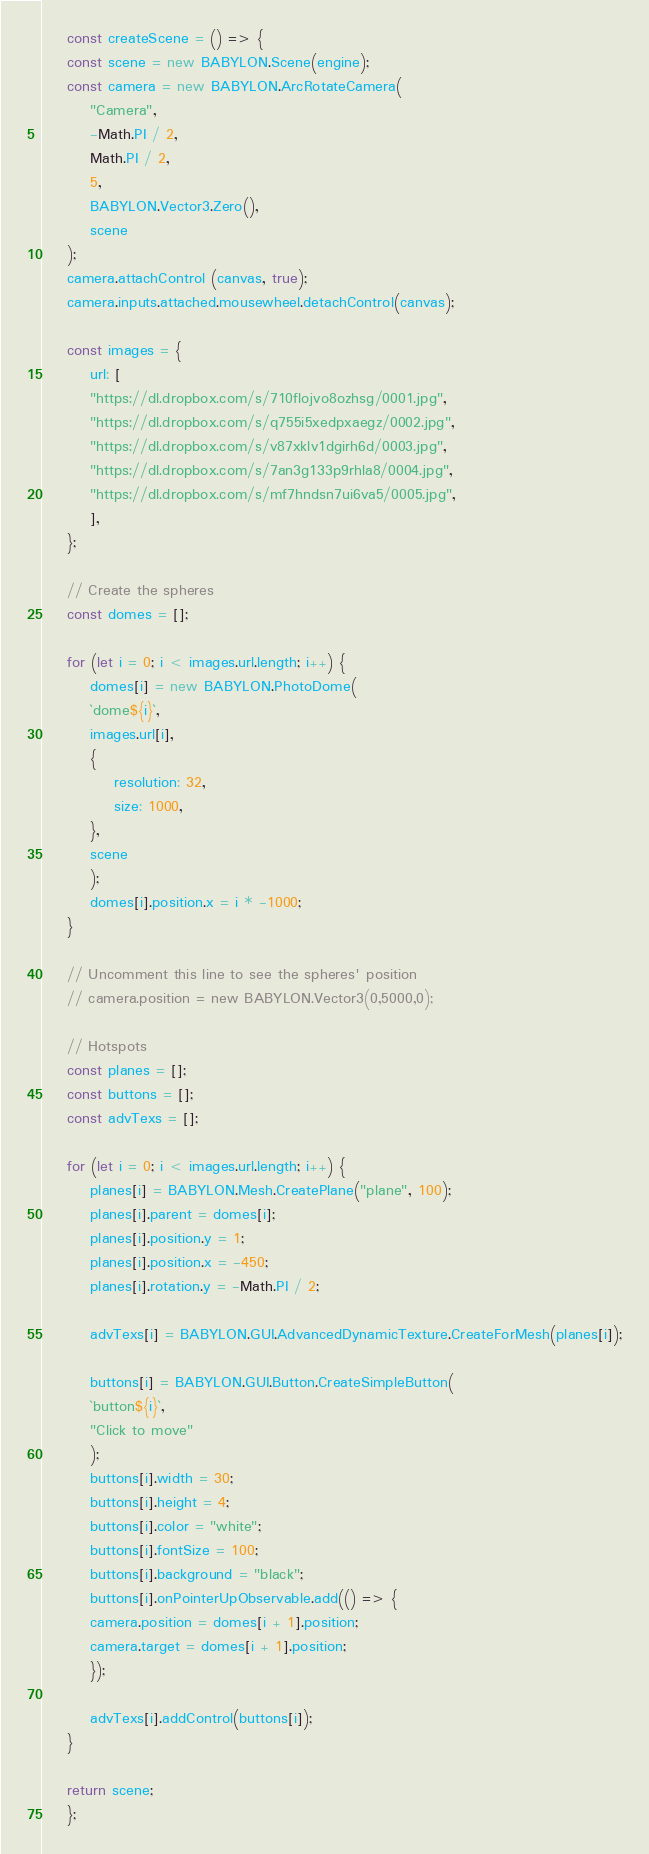<code> <loc_0><loc_0><loc_500><loc_500><_JavaScript_>    const createScene = () => {
    const scene = new BABYLON.Scene(engine);
    const camera = new BABYLON.ArcRotateCamera(
        "Camera",
        -Math.PI / 2,
        Math.PI / 2,
        5,
        BABYLON.Vector3.Zero(),
        scene
    );
    camera.attachControl (canvas, true);
    camera.inputs.attached.mousewheel.detachControl(canvas);

    const images = {
        url: [
        "https://dl.dropbox.com/s/710flojvo8ozhsg/0001.jpg",
        "https://dl.dropbox.com/s/q755i5xedpxaegz/0002.jpg",
        "https://dl.dropbox.com/s/v87xklv1dgirh6d/0003.jpg",
        "https://dl.dropbox.com/s/7an3g133p9rhla8/0004.jpg",
        "https://dl.dropbox.com/s/mf7hndsn7ui6va5/0005.jpg",
        ],
    };

    // Create the spheres
    const domes = [];

    for (let i = 0; i < images.url.length; i++) {
        domes[i] = new BABYLON.PhotoDome(
        `dome${i}`,
        images.url[i],
        {
            resolution: 32,
            size: 1000,
        },
        scene
        );
        domes[i].position.x = i * -1000;
    }

    // Uncomment this line to see the spheres' position
    // camera.position = new BABYLON.Vector3(0,5000,0);

    // Hotspots
    const planes = [];
    const buttons = [];
    const advTexs = [];

    for (let i = 0; i < images.url.length; i++) {
        planes[i] = BABYLON.Mesh.CreatePlane("plane", 100);
        planes[i].parent = domes[i];
        planes[i].position.y = 1;
        planes[i].position.x = -450;
        planes[i].rotation.y = -Math.PI / 2;

        advTexs[i] = BABYLON.GUI.AdvancedDynamicTexture.CreateForMesh(planes[i]);

        buttons[i] = BABYLON.GUI.Button.CreateSimpleButton(
        `button${i}`,
        "Click to move"
        );
        buttons[i].width = 30;
        buttons[i].height = 4;
        buttons[i].color = "white";
        buttons[i].fontSize = 100;
        buttons[i].background = "black";
        buttons[i].onPointerUpObservable.add(() => {
        camera.position = domes[i + 1].position;
        camera.target = domes[i + 1].position;
        });

        advTexs[i].addControl(buttons[i]);
    }

    return scene;
    };
</code> 